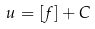Convert formula to latex. <formula><loc_0><loc_0><loc_500><loc_500>u = [ f ] + C</formula> 